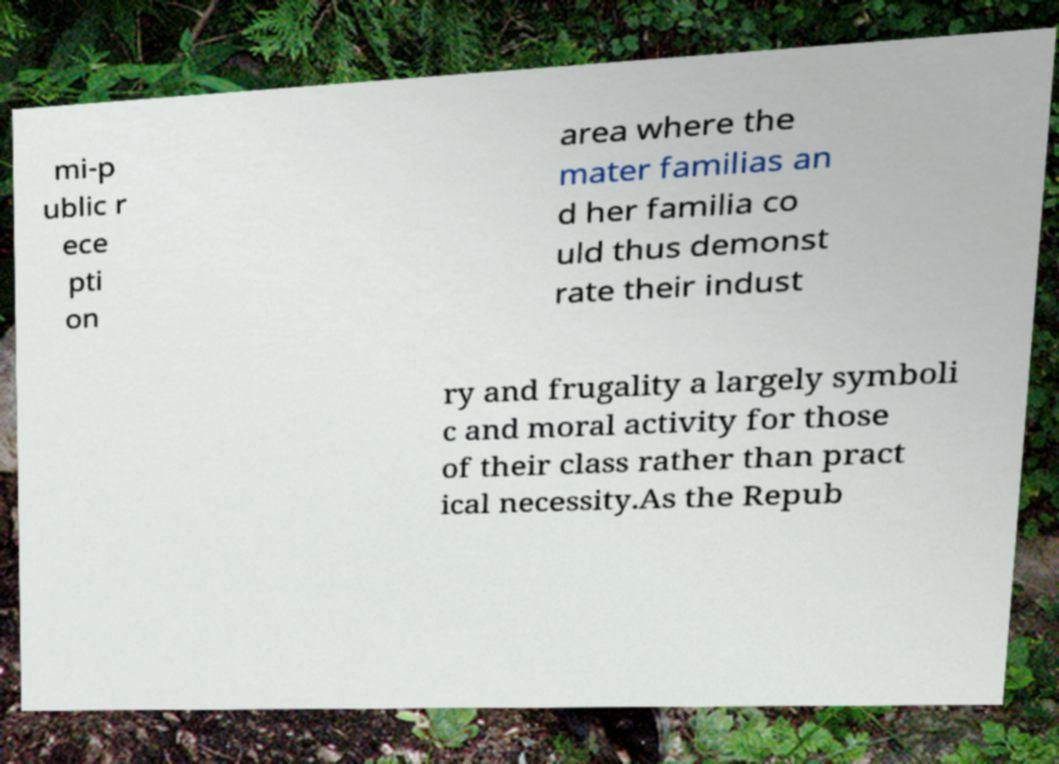Please identify and transcribe the text found in this image. mi-p ublic r ece pti on area where the mater familias an d her familia co uld thus demonst rate their indust ry and frugality a largely symboli c and moral activity for those of their class rather than pract ical necessity.As the Repub 